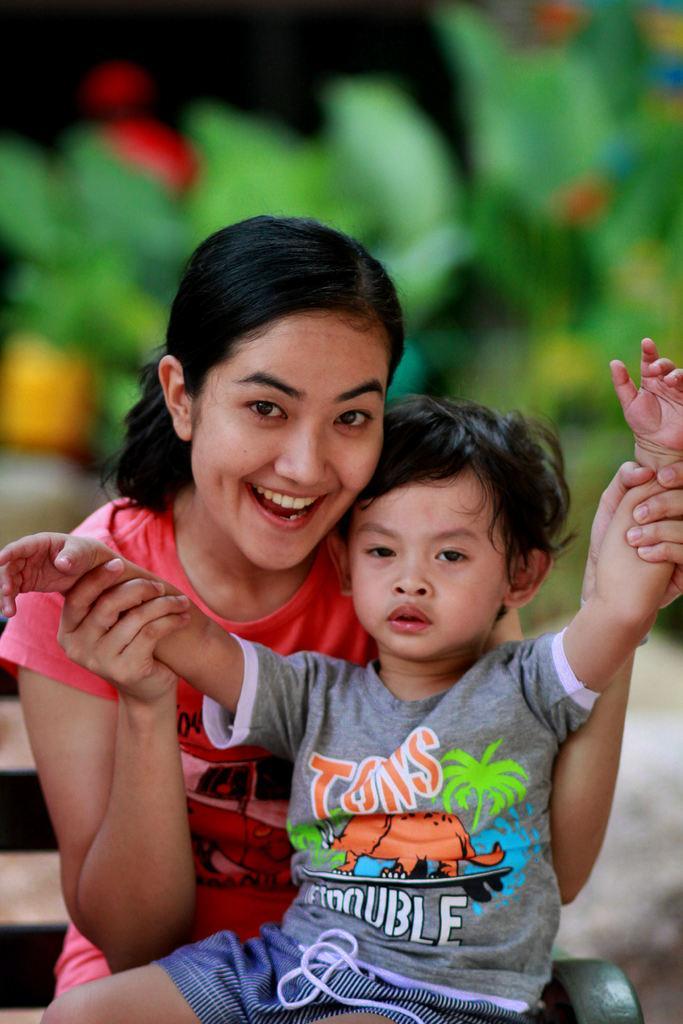Please provide a concise description of this image. In this picture there is a woman wearing wearing a pink color t-shirt sitting on the bench with small boy, smiling and giving pose into the camera. Behind there is a blur background. 